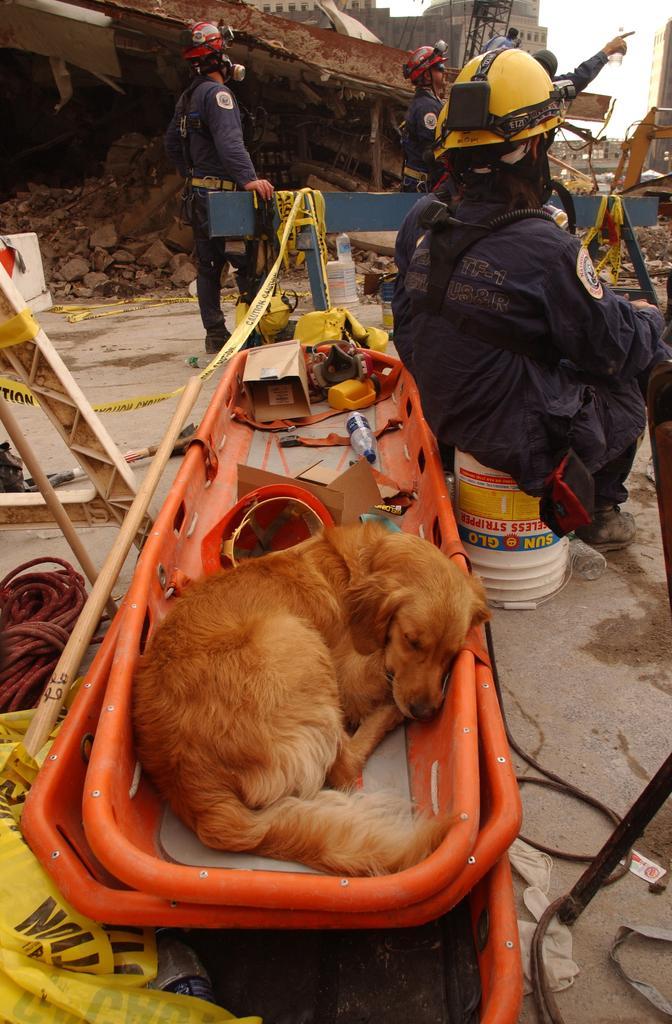Please provide a concise description of this image. In this image, we can see persons wearing clothes and helmets. There is a person on the right side of the image sitting on the bucket. There is a basket in the middle of the image contains helmet, box, bottle and dog. There is a barricade tape in the bottom left and in the middle of the image. There are sticks on the left side of the image. 